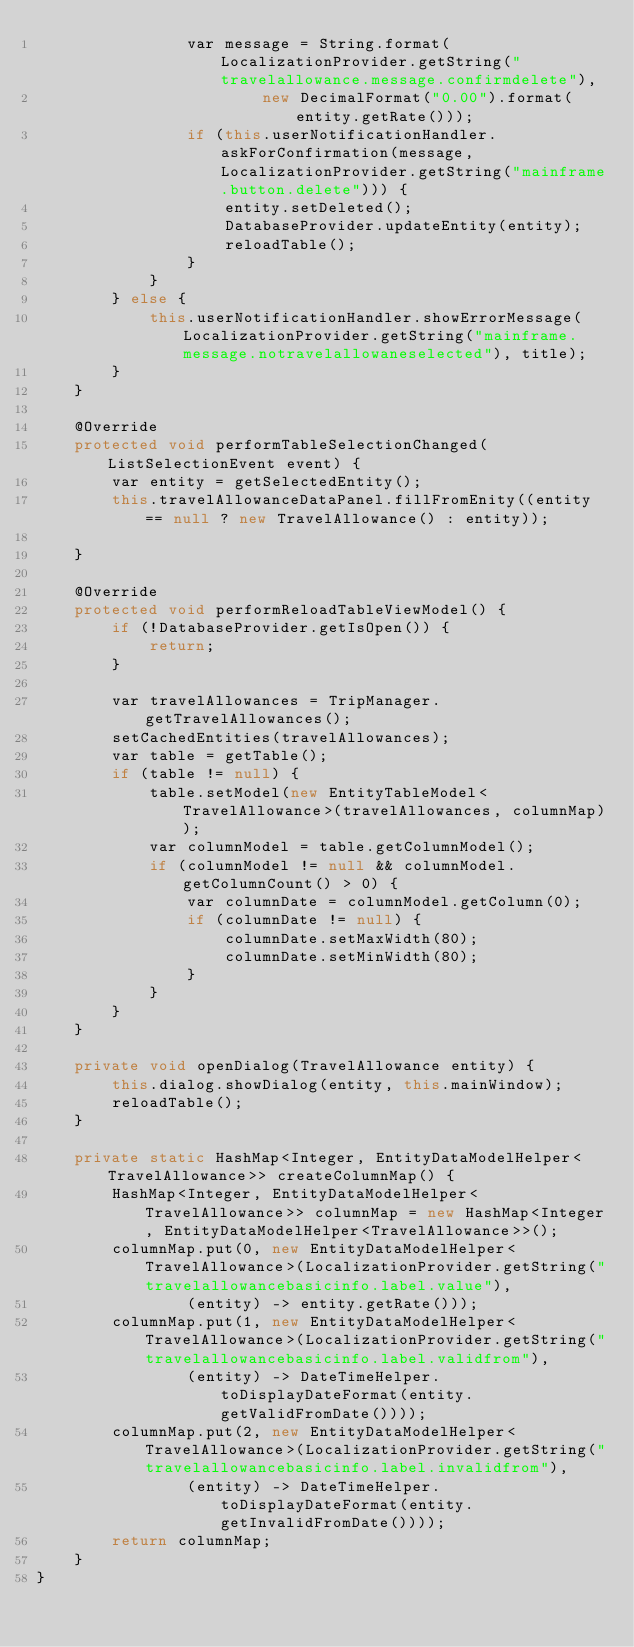<code> <loc_0><loc_0><loc_500><loc_500><_Java_>                var message = String.format(LocalizationProvider.getString("travelallowance.message.confirmdelete"),
                        new DecimalFormat("0.00").format(entity.getRate()));
                if (this.userNotificationHandler.askForConfirmation(message, LocalizationProvider.getString("mainframe.button.delete"))) {
                    entity.setDeleted();
                    DatabaseProvider.updateEntity(entity);
                    reloadTable();
                }
            }
        } else {            
            this.userNotificationHandler.showErrorMessage(LocalizationProvider.getString("mainframe.message.notravelallowaneselected"), title);
        }
    }

    @Override
    protected void performTableSelectionChanged(ListSelectionEvent event) {
        var entity = getSelectedEntity();
        this.travelAllowanceDataPanel.fillFromEnity((entity == null ? new TravelAllowance() : entity));
        
    }
    
    @Override
    protected void performReloadTableViewModel() {
        if (!DatabaseProvider.getIsOpen()) {
            return;
        }
        
        var travelAllowances = TripManager.getTravelAllowances();
        setCachedEntities(travelAllowances);
        var table = getTable();
        if (table != null) {
            table.setModel(new EntityTableModel<TravelAllowance>(travelAllowances, columnMap));
            var columnModel = table.getColumnModel();
            if (columnModel != null && columnModel.getColumnCount() > 0) {
                var columnDate = columnModel.getColumn(0);
                if (columnDate != null) {
                    columnDate.setMaxWidth(80);
                    columnDate.setMinWidth(80);
                }
            }
        }
    }
    
    private void openDialog(TravelAllowance entity) {
        this.dialog.showDialog(entity, this.mainWindow);
        reloadTable();
    }

    private static HashMap<Integer, EntityDataModelHelper<TravelAllowance>> createColumnMap() {
        HashMap<Integer, EntityDataModelHelper<TravelAllowance>> columnMap = new HashMap<Integer, EntityDataModelHelper<TravelAllowance>>();
        columnMap.put(0, new EntityDataModelHelper<TravelAllowance>(LocalizationProvider.getString("travelallowancebasicinfo.label.value"),
                (entity) -> entity.getRate()));
        columnMap.put(1, new EntityDataModelHelper<TravelAllowance>(LocalizationProvider.getString("travelallowancebasicinfo.label.validfrom"),
                (entity) -> DateTimeHelper.toDisplayDateFormat(entity.getValidFromDate())));
        columnMap.put(2, new EntityDataModelHelper<TravelAllowance>(LocalizationProvider.getString("travelallowancebasicinfo.label.invalidfrom"),
                (entity) -> DateTimeHelper.toDisplayDateFormat(entity.getInvalidFromDate())));
        return columnMap;
    }
}
</code> 